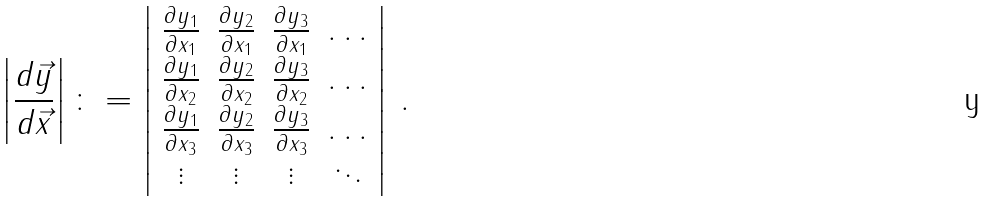Convert formula to latex. <formula><loc_0><loc_0><loc_500><loc_500>\left | \frac { d \vec { y } } { d \vec { x } } \right | \colon = \left | \begin{array} { c c c c } \frac { \partial y _ { 1 } } { \partial x _ { 1 } } & \frac { \partial y _ { 2 } } { \partial x _ { 1 } } & \frac { \partial y _ { 3 } } { \partial x _ { 1 } } & \dots \\ \frac { \partial y _ { 1 } } { \partial x _ { 2 } } & \frac { \partial y _ { 2 } } { \partial x _ { 2 } } & \frac { \partial y _ { 3 } } { \partial x _ { 2 } } & \dots \\ \frac { \partial y _ { 1 } } { \partial x _ { 3 } } & \frac { \partial y _ { 2 } } { \partial x _ { 3 } } & \frac { \partial y _ { 3 } } { \partial x _ { 3 } } & \dots \\ \vdots & \vdots & \vdots & \ddots \end{array} \right | \, .</formula> 